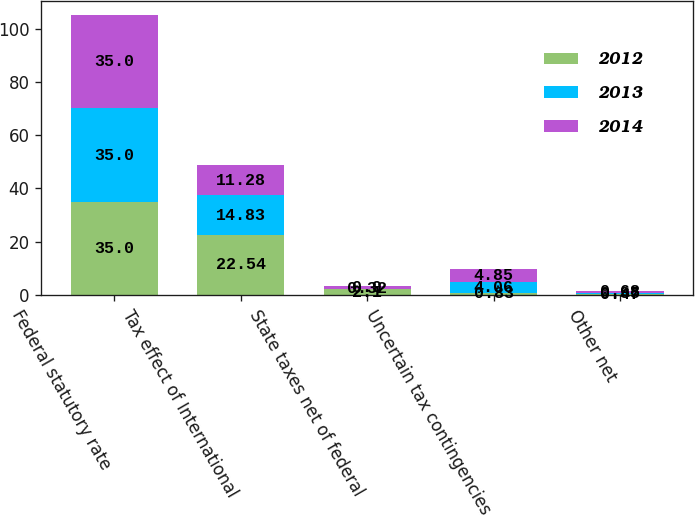Convert chart to OTSL. <chart><loc_0><loc_0><loc_500><loc_500><stacked_bar_chart><ecel><fcel>Federal statutory rate<fcel>Tax effect of International<fcel>State taxes net of federal<fcel>Uncertain tax contingencies<fcel>Other net<nl><fcel>2012<fcel>35<fcel>22.54<fcel>2.1<fcel>0.83<fcel>0.47<nl><fcel>2013<fcel>35<fcel>14.83<fcel>0.32<fcel>4.06<fcel>0.35<nl><fcel>2014<fcel>35<fcel>11.28<fcel>0.9<fcel>4.85<fcel>0.68<nl></chart> 